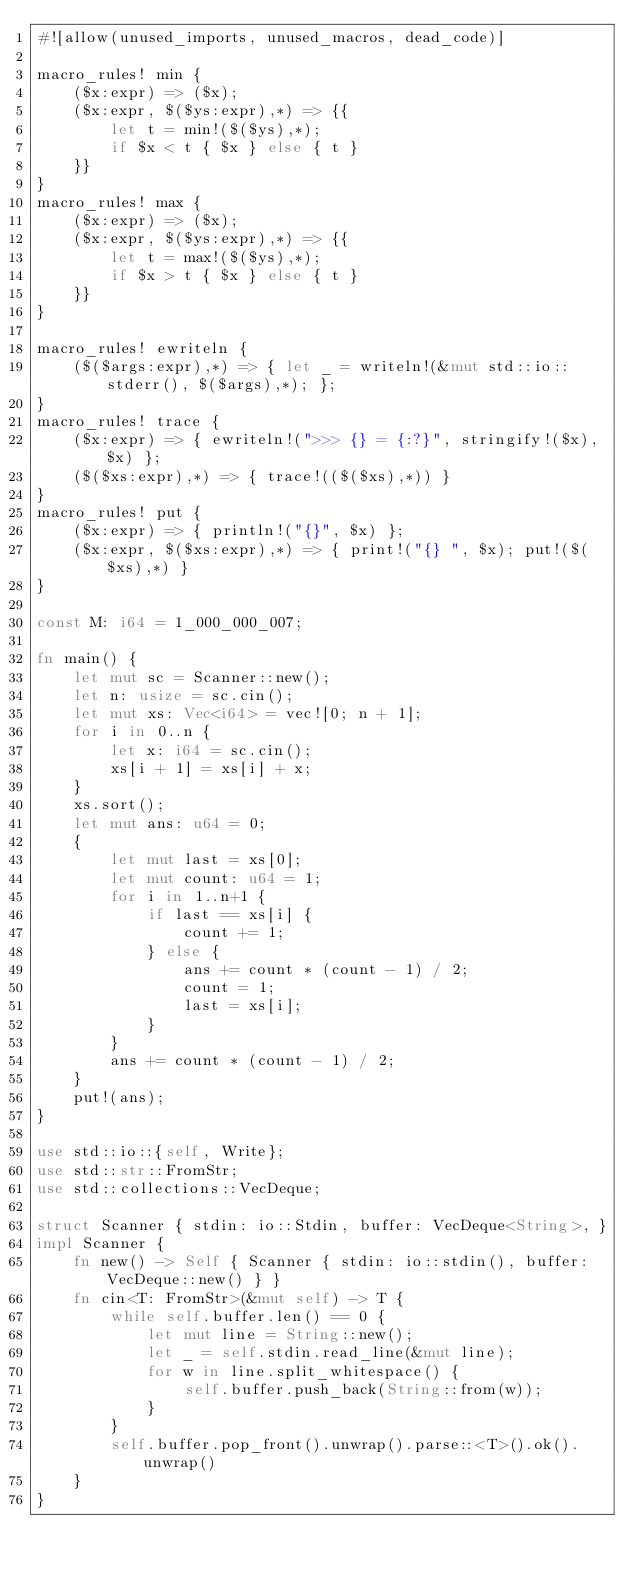Convert code to text. <code><loc_0><loc_0><loc_500><loc_500><_Rust_>#![allow(unused_imports, unused_macros, dead_code)]

macro_rules! min {
    ($x:expr) => ($x);
    ($x:expr, $($ys:expr),*) => {{
        let t = min!($($ys),*);
        if $x < t { $x } else { t }
    }}
}
macro_rules! max {
    ($x:expr) => ($x);
    ($x:expr, $($ys:expr),*) => {{
        let t = max!($($ys),*);
        if $x > t { $x } else { t }
    }}
}

macro_rules! ewriteln {
    ($($args:expr),*) => { let _ = writeln!(&mut std::io::stderr(), $($args),*); };
}
macro_rules! trace {
    ($x:expr) => { ewriteln!(">>> {} = {:?}", stringify!($x), $x) };
    ($($xs:expr),*) => { trace!(($($xs),*)) }
}
macro_rules! put {
    ($x:expr) => { println!("{}", $x) };
    ($x:expr, $($xs:expr),*) => { print!("{} ", $x); put!($($xs),*) }
}

const M: i64 = 1_000_000_007;

fn main() {
    let mut sc = Scanner::new();
    let n: usize = sc.cin();
    let mut xs: Vec<i64> = vec![0; n + 1];
    for i in 0..n {
        let x: i64 = sc.cin();
        xs[i + 1] = xs[i] + x;
    }
    xs.sort();
    let mut ans: u64 = 0;
    {
        let mut last = xs[0];
        let mut count: u64 = 1;
        for i in 1..n+1 {
            if last == xs[i] {
                count += 1;
            } else {
                ans += count * (count - 1) / 2;
                count = 1;
                last = xs[i];
            }
        }
        ans += count * (count - 1) / 2;
    }
    put!(ans);
}

use std::io::{self, Write};
use std::str::FromStr;
use std::collections::VecDeque;

struct Scanner { stdin: io::Stdin, buffer: VecDeque<String>, }
impl Scanner {
    fn new() -> Self { Scanner { stdin: io::stdin(), buffer: VecDeque::new() } }
    fn cin<T: FromStr>(&mut self) -> T {
        while self.buffer.len() == 0 {
            let mut line = String::new();
            let _ = self.stdin.read_line(&mut line);
            for w in line.split_whitespace() {
                self.buffer.push_back(String::from(w));
            }
        }
        self.buffer.pop_front().unwrap().parse::<T>().ok().unwrap()
    }
}
</code> 